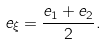<formula> <loc_0><loc_0><loc_500><loc_500>e _ { \xi } = \frac { e _ { 1 } + e _ { 2 } } { 2 } .</formula> 